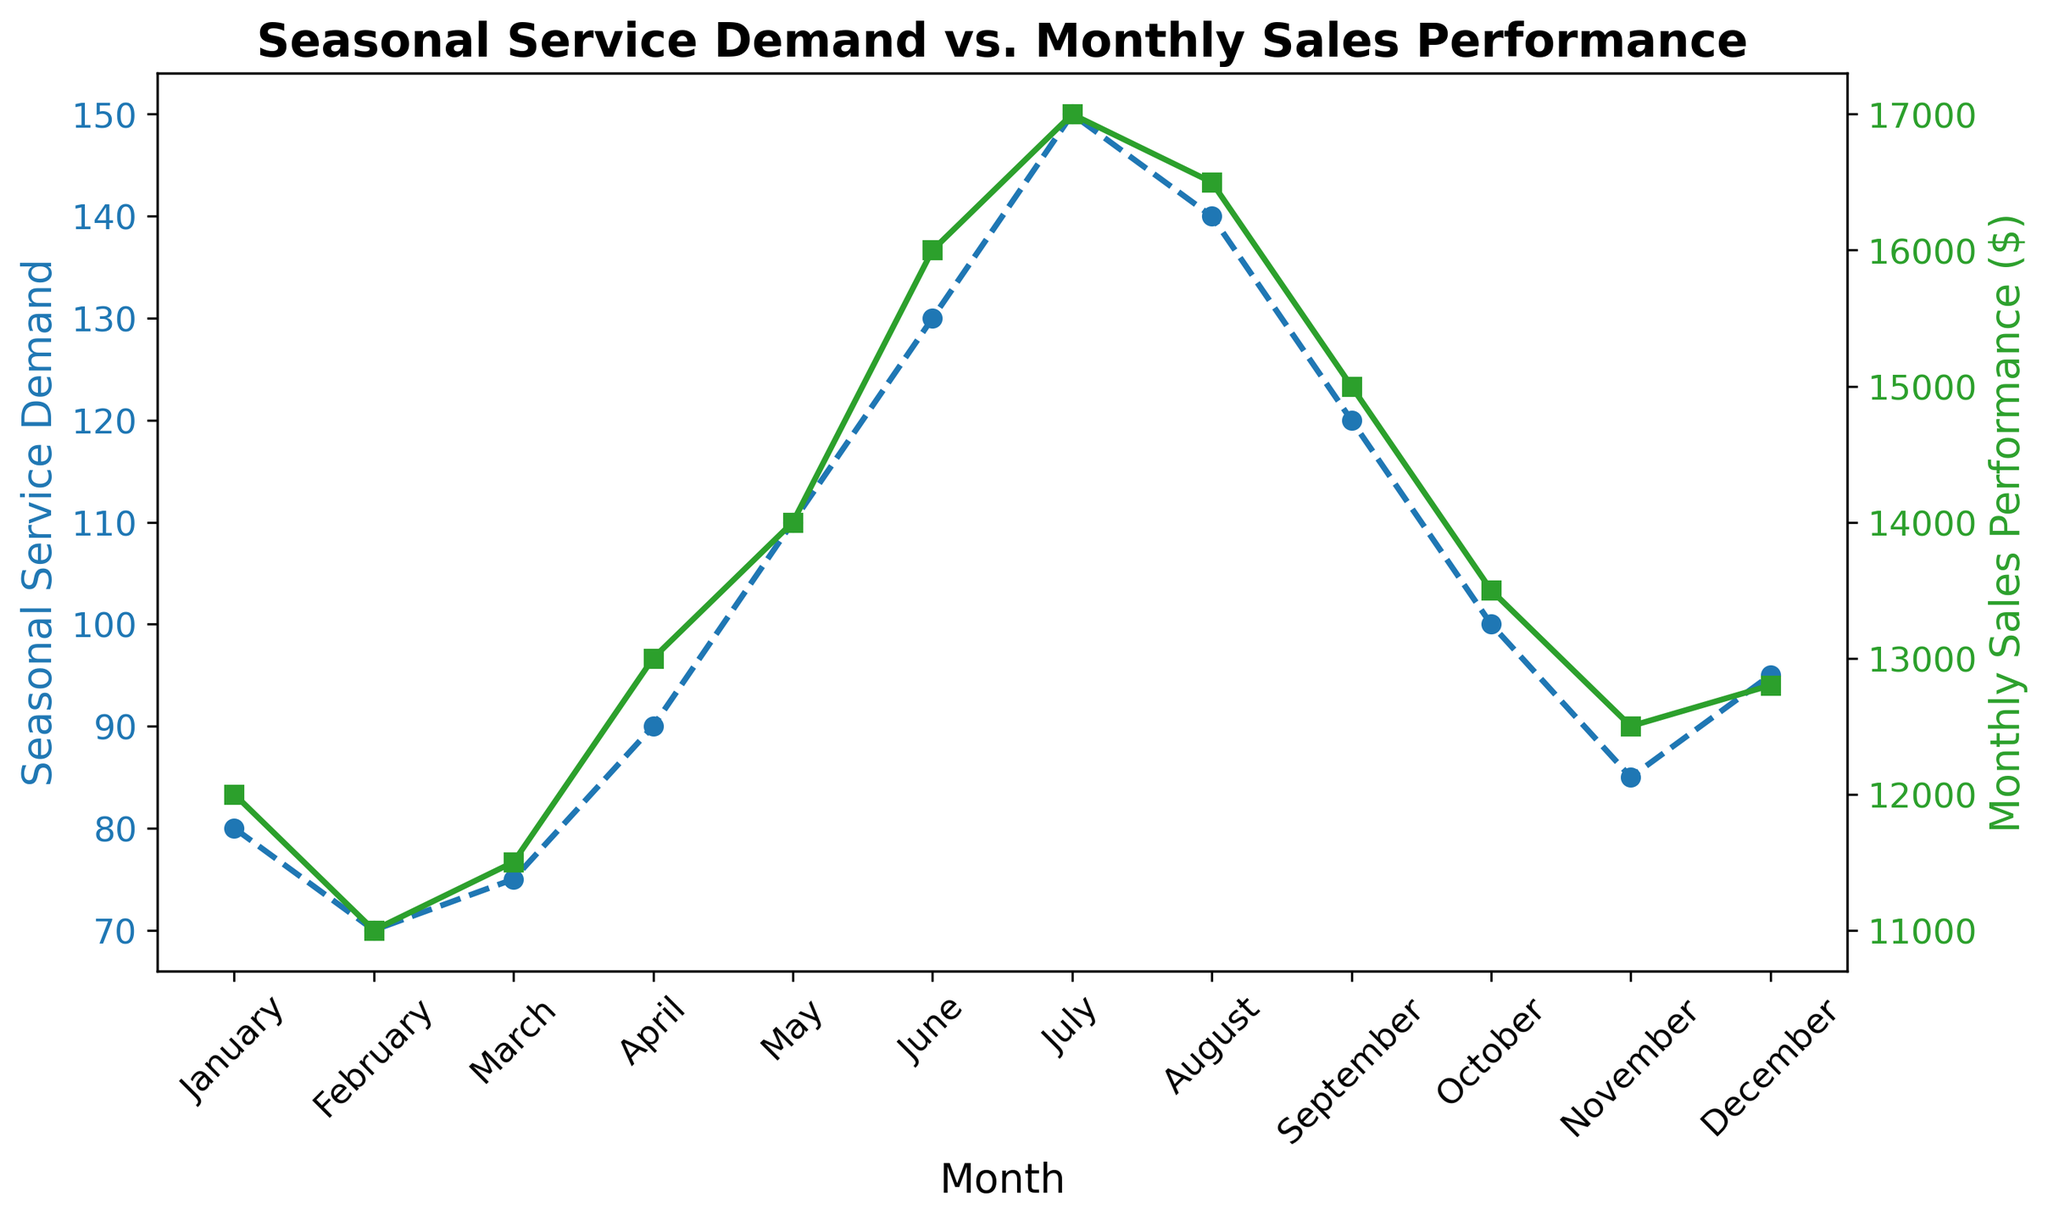Which month has the highest Seasonal Service Demand? By looking at the blue line with circle markers, we can see that July has the highest Seasonal Service Demand with a value of 150.
Answer: July Which month has the lowest Monthly Sales Performance? By examining the green line with square markers, we notice that February has the lowest Monthly Sales Performance with a value of $11,000.
Answer: February Compare the Seasonal Service Demand between June and July. Which month has a higher demand and by how much? June has a Seasonal Service Demand of 130, while July's is 150. Subtracting 130 from 150 gives us 20. July has a higher demand by 20 units.
Answer: July by 20 units What is the average Monthly Sales Performance for the months of May, June, and July? Summing the Monthly Sales Performance for May ($14,000), June ($16,000), and July ($17,000) gives us 14,000 + 16,000 + 17,000 = 47,000. Dividing this sum by 3 (the number of months) gives us 47,000 / 3 ≈ $15,667.
Answer: $15,667 Which month shows a higher increase in Seasonal Service Demand compared to the previous month: March to April, or April to May? From March to April, the demand increased from 75 to 90, which is an increase of 15. From April to May, it increased from 90 to 110, an increase of 20. So, the increase from April to May is higher by 5 units.
Answer: April to May During which month is the gap between Seasonal Service Demand and Monthly Sales Performance the smallest? By visual inspection, November shows the closest values between the blue line (85) and the green line ($12,500), making the gap smallest.
Answer: November Look at the trend from January to December. Describe the overall pattern for Seasonal Service Demand. The blue line trends upward from January (80) peaking in July (150) and then gradually declines toward December (95), indicating seasonality with a peak mid-year.
Answer: Upward to July, then downward What is the difference in Monthly Sales Performance between the highest and lowest months? The highest Monthly Sales Performance is in July ($17,000) and the lowest is in February ($11,000). The difference is 17,000 - 11,000 = $6,000.
Answer: $6,000 Identify the months where both Seasonal Service Demand and Monthly Sales Performance increase from the previous month. By tracking the rise from previous months, both indicators increase from March to April and May to June.
Answer: April, June 